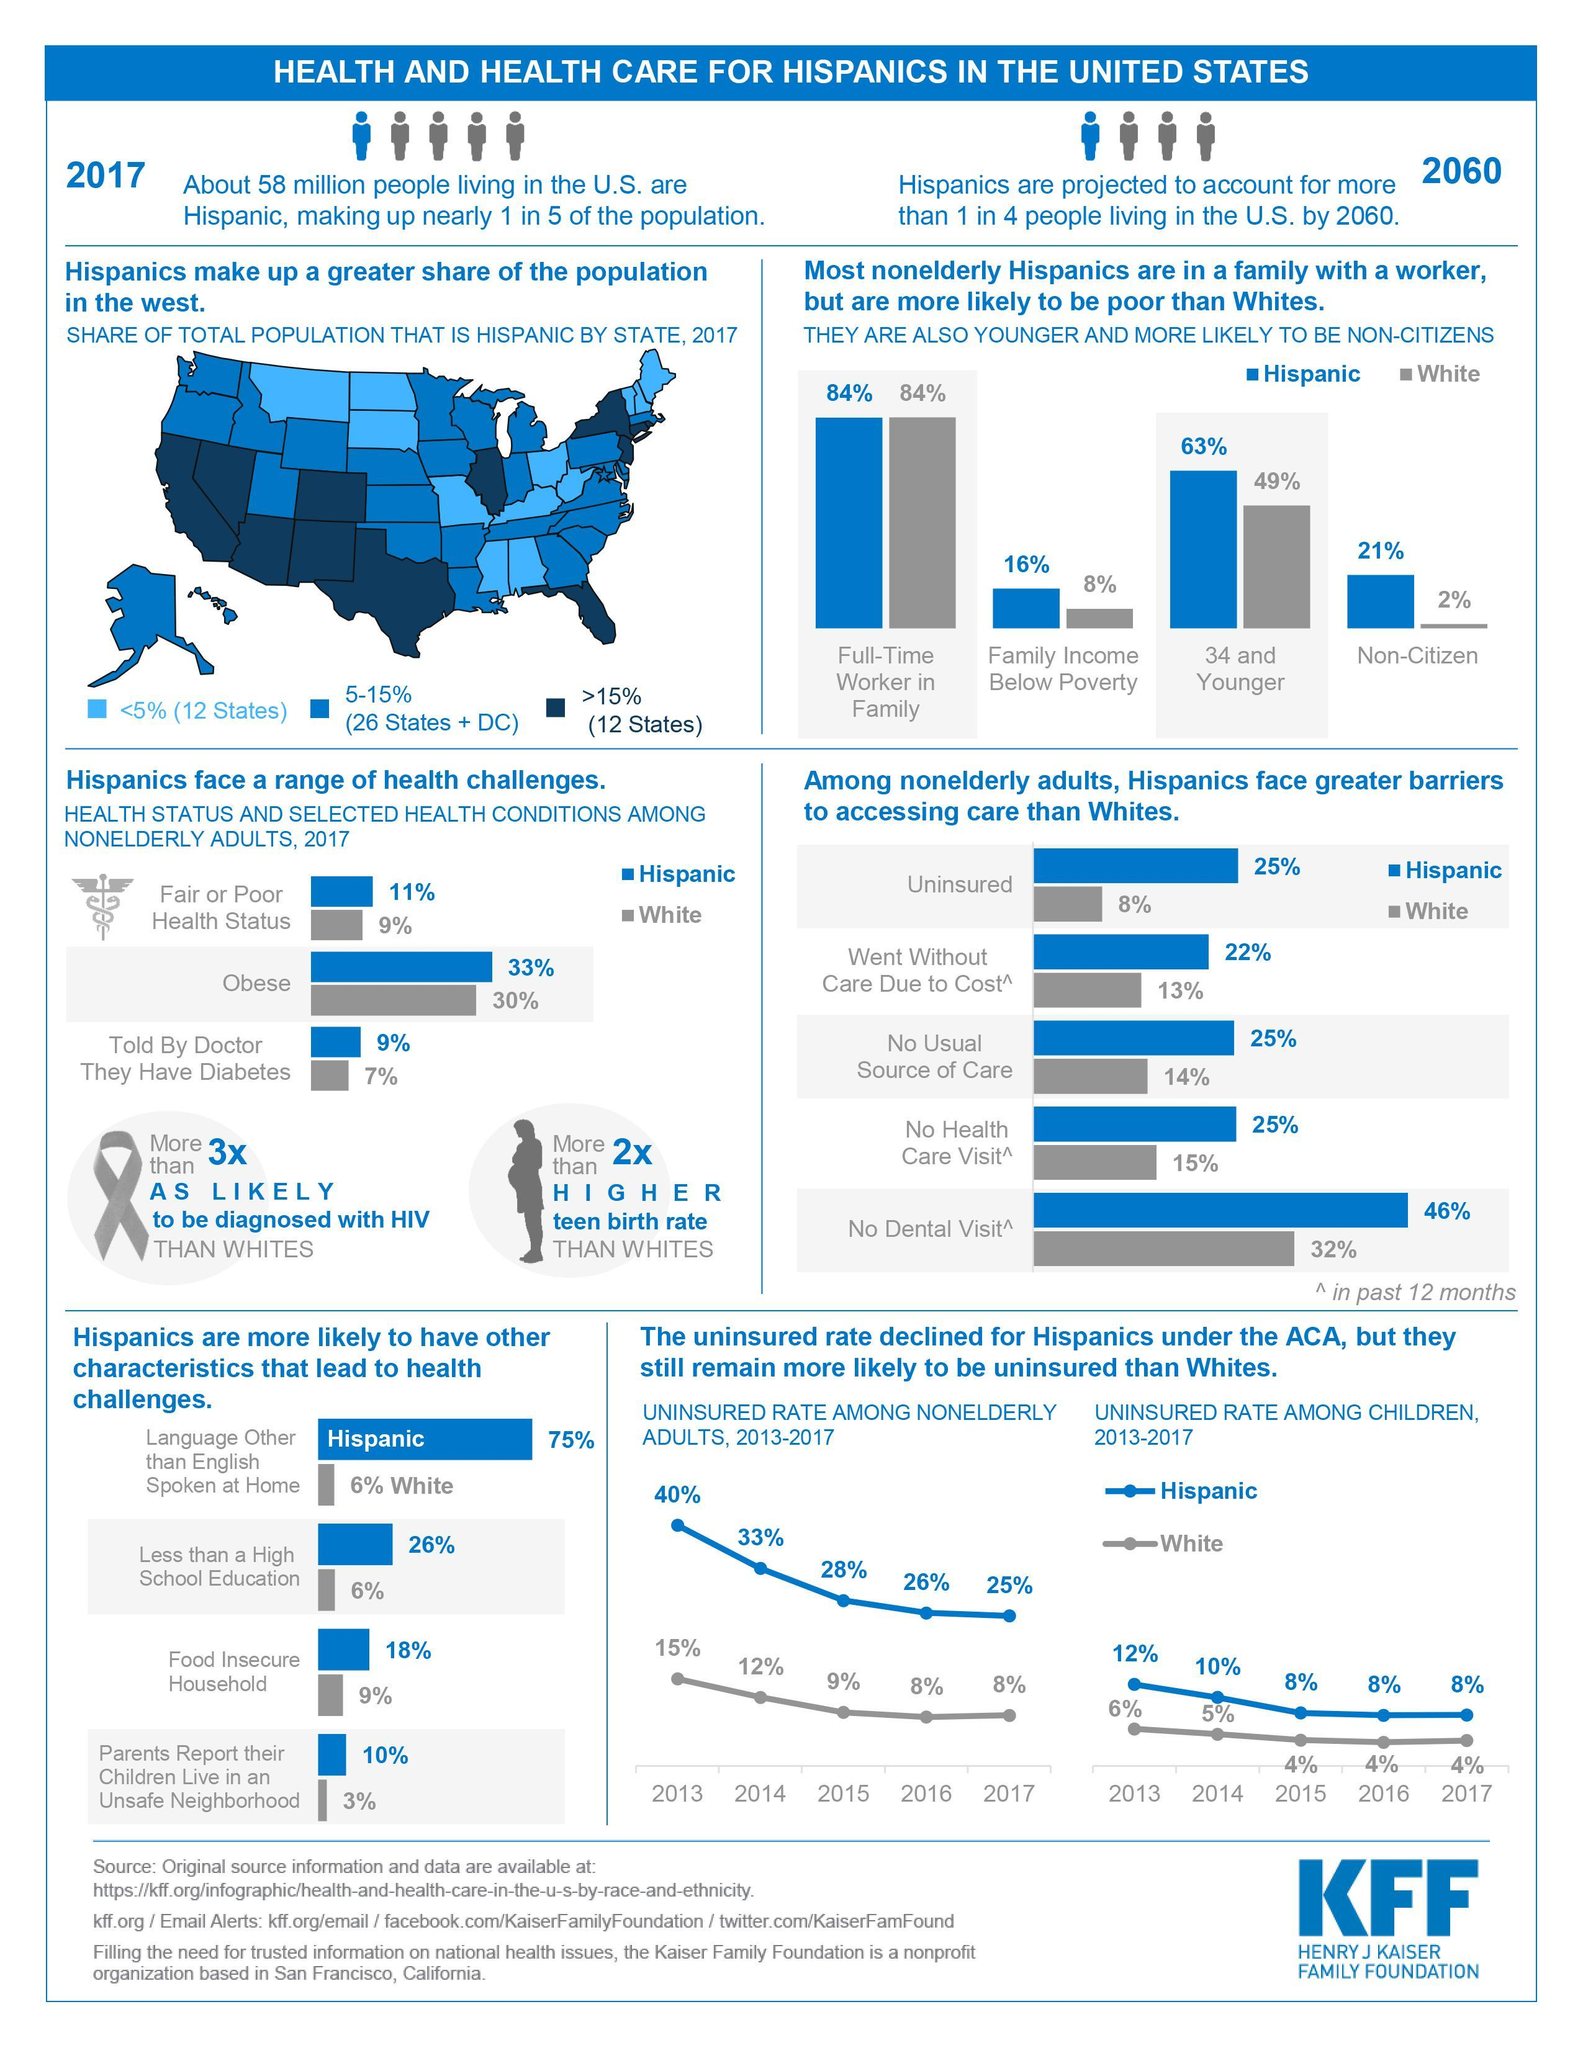What does 75% of Hispanic speak?
Answer the question with a short phrase. Language Other than English Which is the source of the infographic? HENRY J KAISER FAMILY FOUNDATION What percentage of Hispanics are in the age 34 and younger? 63% What percentage of Hispanics live in most number of states as of 2017? 5-15% What percent of Hispanic population is obese? 33% 